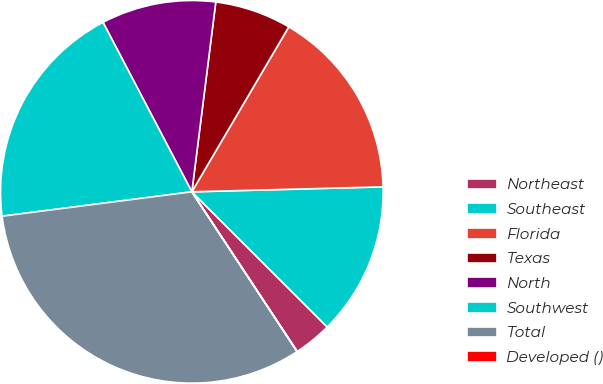Convert chart to OTSL. <chart><loc_0><loc_0><loc_500><loc_500><pie_chart><fcel>Northeast<fcel>Southeast<fcel>Florida<fcel>Texas<fcel>North<fcel>Southwest<fcel>Total<fcel>Developed ()<nl><fcel>3.23%<fcel>12.9%<fcel>16.13%<fcel>6.46%<fcel>9.68%<fcel>19.35%<fcel>32.24%<fcel>0.01%<nl></chart> 